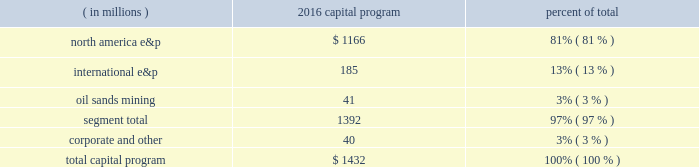Outlook commodity prices are the most significant factor impacting our revenues , profitability , operating cash flows and the amount of capital available to reinvest into our business .
Commodity prices began declining in the second half of 2014 and continued through 2015 and into 2016 .
We believe we can manage in this lower commodity price cycle through operational execution , efficiency improvements , cost reductions , capital discipline and portfolio optimization , while continuing to focus on balance sheet protection .
Capital program our board of directors approved a capital program of $ 1.4 billion for 2016 .
We intend to be flexible with respect to our capital allocation decisions in light of this challenged commodity pricing environment .
With that in mind , we have engaged in an active program to divest of non-core assets , which together with our anticipated cash flows from operations , plus the savings embedded from the cost reductions we have put in place , should allow us to meet our current capital program , operating costs , debt service and dividends .
The discipline undertaken as part of a real-time evaluation of our revenues , expenditures , and asset dispositions should allow us to live within our means .
Our capital program is broken down by reportable segment in the table below : ( in millions ) 2016 capital program percent of .
North america e&p 2013 approximately $ 1.2 billion of our capital program is allocated to our three core u.s .
Resource plays .
Eagle ford - approximately $ 600 million is planned , we expect to average five rigs and bring 124-132 gross-operated wells to sales .
Included in eagle ford spending is approximately $ 520 million for drilling and completions .
The 2016 drilling program will continue to focus on the co-development of the lower and upper eagle ford horizons as well as austin chalk in the core of the play .
Oklahoma resource basins - spending of approximately $ 200 million is targeted , we expect to average two rigs which will focus primarily on lease retention in the stack and delineation of the meramec , and bring 20-22 gross-operated wells to sales .
Spending includes approximately $ 195 million for drilling and completions , including $ 55 million for outside-operated activity .
We expect to be approximately 70% ( 70 % ) held by production in the stack by year end , with scoop already 90% ( 90 % ) held by production .
Bakken - we plan to spend just under $ 200 million in north dakota .
Drilling activity will average one rig for half of 2016 and bring online 13-15 gross-operated wells .
Bakken spending includes approximately $ 150 million for drilling and completions , including $ 75 million for outside-operated activity .
Facilities and infrastructure spending will be significantly lower than 2015 with the next phase of the water-gathering system scheduled to be complete in the second half of 2016 .
International e&p 2013 approximately $ 170 million of our capital program is dedicated to our international assets , primarily in e.g .
And the kurdistan region of iraq .
The alba field compression project in e.g .
Remains on schedule to start up by mid- year , and will extend plateau production by two years as well as the asset 2019s life by up to eight years .
Approximately $ 30 million of our capital program will be spent on a targeted exploration program impacting both the north america e&p and the international e&p segments .
Activity in 2016 is limited to fulfilling existing commitments in the gulf of mexico and gabon , with no operated exploration wells planned .
Oil sands mining 2013 we expect to spend $ 40 million of the capital program for sustaining capital projects .
The remainder of our capital program consists of corporate and other and is expected to total approximately $ 40 million .
For information about expected exploration and development activities more specific to individual assets , see item 1 .
Business .
Production volumes we forecast 2016 production available for sale from the combined north america e&p and international e&p segments , excluding libya , to average 335 to 355 net mboed and the osm segment to average 40 to 50 net mbbld of synthetic crude oil. .
Was 2016 spending greater for international e&p than for oil sands mining? 
Computations: (185 > 41)
Answer: yes. 